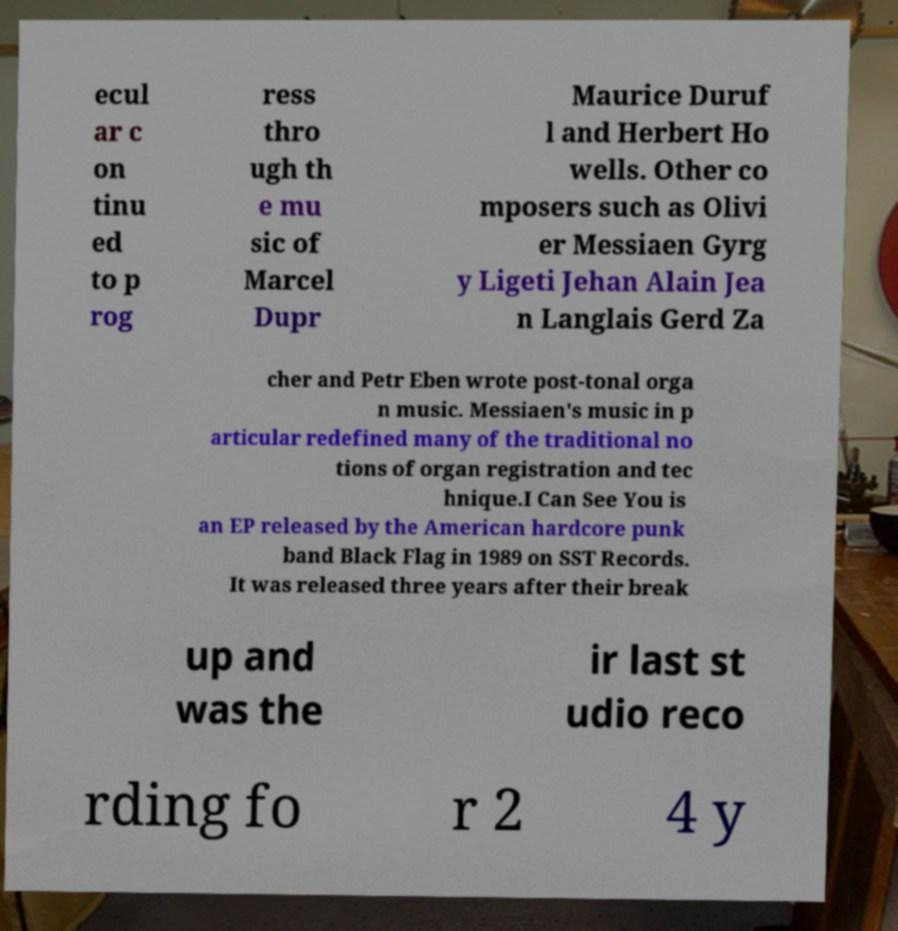There's text embedded in this image that I need extracted. Can you transcribe it verbatim? ecul ar c on tinu ed to p rog ress thro ugh th e mu sic of Marcel Dupr Maurice Duruf l and Herbert Ho wells. Other co mposers such as Olivi er Messiaen Gyrg y Ligeti Jehan Alain Jea n Langlais Gerd Za cher and Petr Eben wrote post-tonal orga n music. Messiaen's music in p articular redefined many of the traditional no tions of organ registration and tec hnique.I Can See You is an EP released by the American hardcore punk band Black Flag in 1989 on SST Records. It was released three years after their break up and was the ir last st udio reco rding fo r 2 4 y 